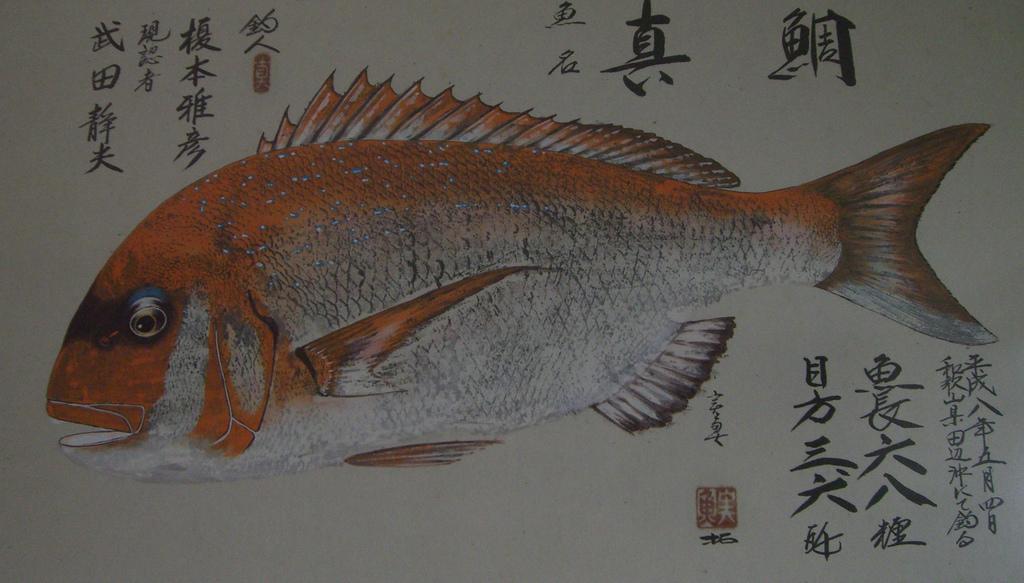Please provide a concise description of this image. In this image we can see a picture. In the picture there are fish and some text written on the paper. 